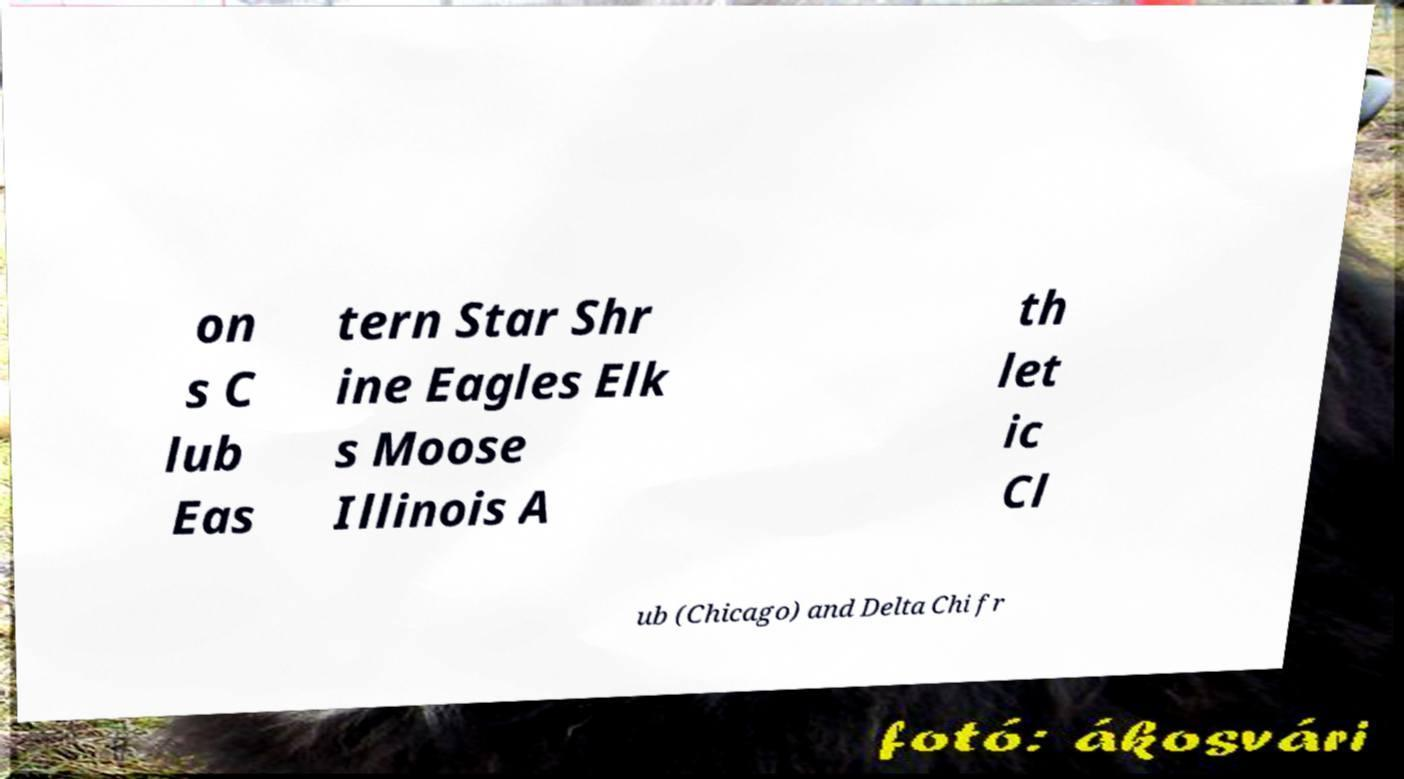Can you read and provide the text displayed in the image?This photo seems to have some interesting text. Can you extract and type it out for me? on s C lub Eas tern Star Shr ine Eagles Elk s Moose Illinois A th let ic Cl ub (Chicago) and Delta Chi fr 